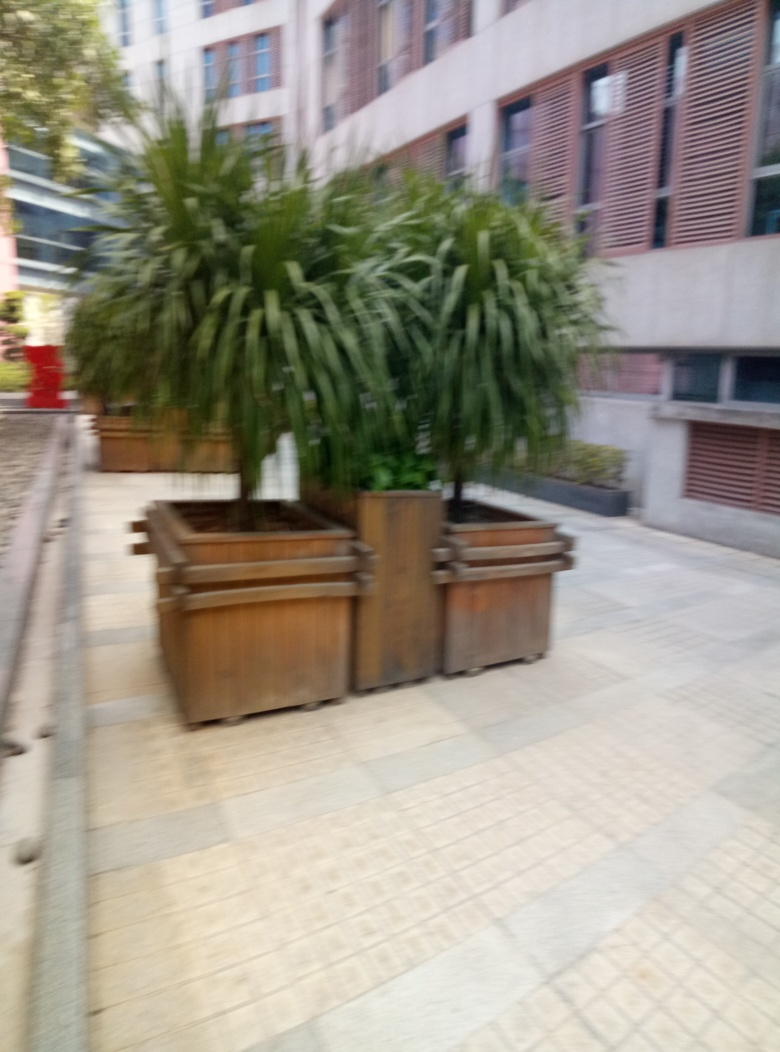Are there any people or animals in this photo? There are no clearly identifiable people or animals in this image. The focus is on the planters and vegetation, and the blurry quality obscures finer details that might be present in the background. 